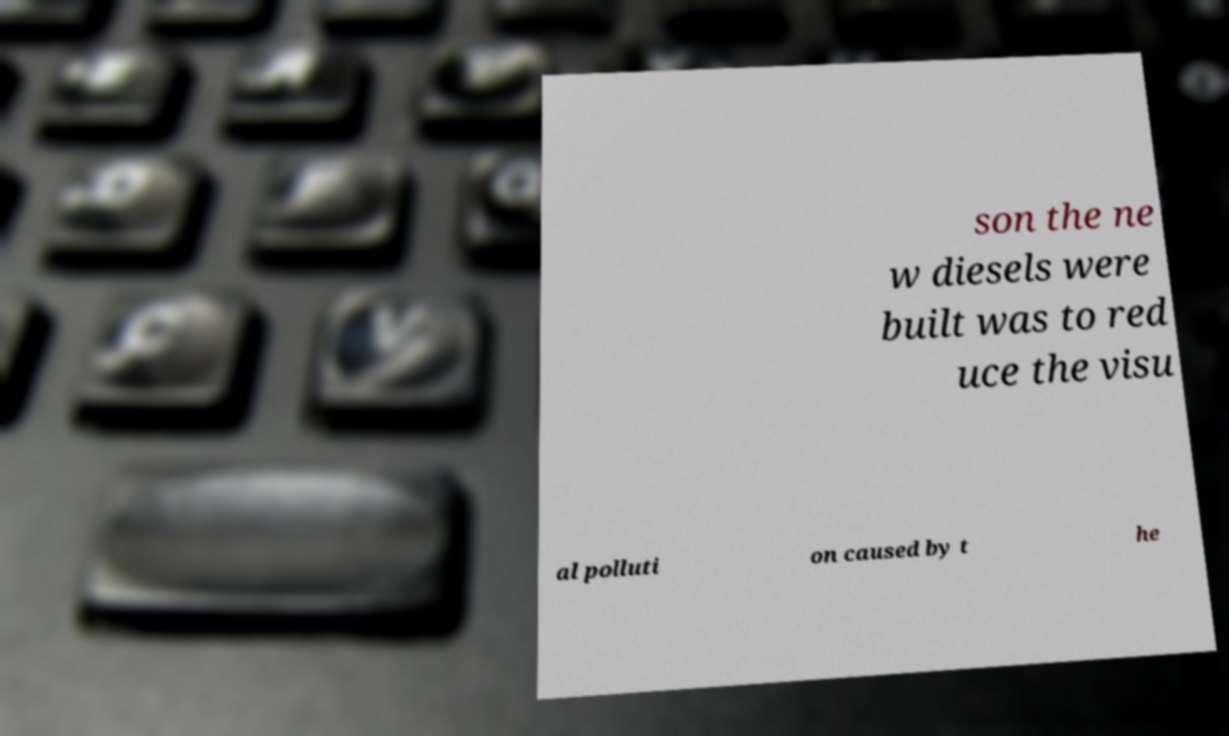There's text embedded in this image that I need extracted. Can you transcribe it verbatim? son the ne w diesels were built was to red uce the visu al polluti on caused by t he 